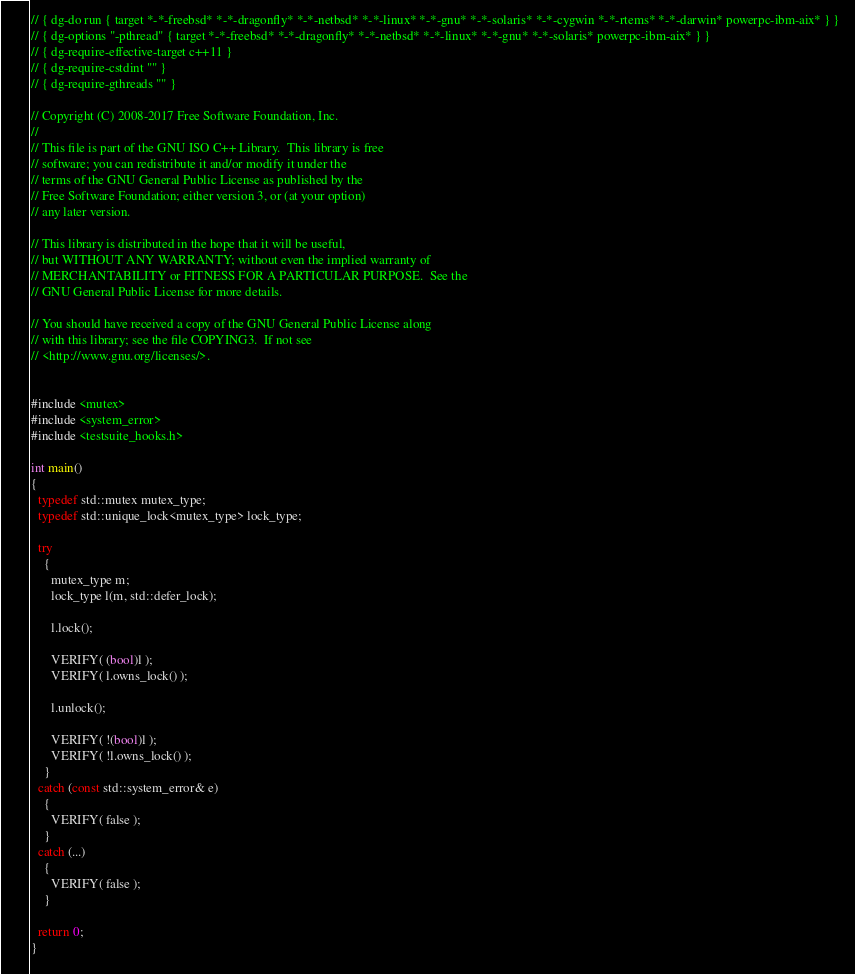<code> <loc_0><loc_0><loc_500><loc_500><_C++_>// { dg-do run { target *-*-freebsd* *-*-dragonfly* *-*-netbsd* *-*-linux* *-*-gnu* *-*-solaris* *-*-cygwin *-*-rtems* *-*-darwin* powerpc-ibm-aix* } }
// { dg-options "-pthread" { target *-*-freebsd* *-*-dragonfly* *-*-netbsd* *-*-linux* *-*-gnu* *-*-solaris* powerpc-ibm-aix* } }
// { dg-require-effective-target c++11 }
// { dg-require-cstdint "" }
// { dg-require-gthreads "" }

// Copyright (C) 2008-2017 Free Software Foundation, Inc.
//
// This file is part of the GNU ISO C++ Library.  This library is free
// software; you can redistribute it and/or modify it under the
// terms of the GNU General Public License as published by the
// Free Software Foundation; either version 3, or (at your option)
// any later version.

// This library is distributed in the hope that it will be useful,
// but WITHOUT ANY WARRANTY; without even the implied warranty of
// MERCHANTABILITY or FITNESS FOR A PARTICULAR PURPOSE.  See the
// GNU General Public License for more details.

// You should have received a copy of the GNU General Public License along
// with this library; see the file COPYING3.  If not see
// <http://www.gnu.org/licenses/>.


#include <mutex>
#include <system_error>
#include <testsuite_hooks.h>

int main()
{
  typedef std::mutex mutex_type;
  typedef std::unique_lock<mutex_type> lock_type;

  try 
    {
      mutex_type m;
      lock_type l(m, std::defer_lock);

      l.lock();

      VERIFY( (bool)l );
      VERIFY( l.owns_lock() );

      l.unlock();
      
      VERIFY( !(bool)l );
      VERIFY( !l.owns_lock() );
    }
  catch (const std::system_error& e)
    {
      VERIFY( false );
    }
  catch (...)
    {
      VERIFY( false );
    }

  return 0;
}
</code> 